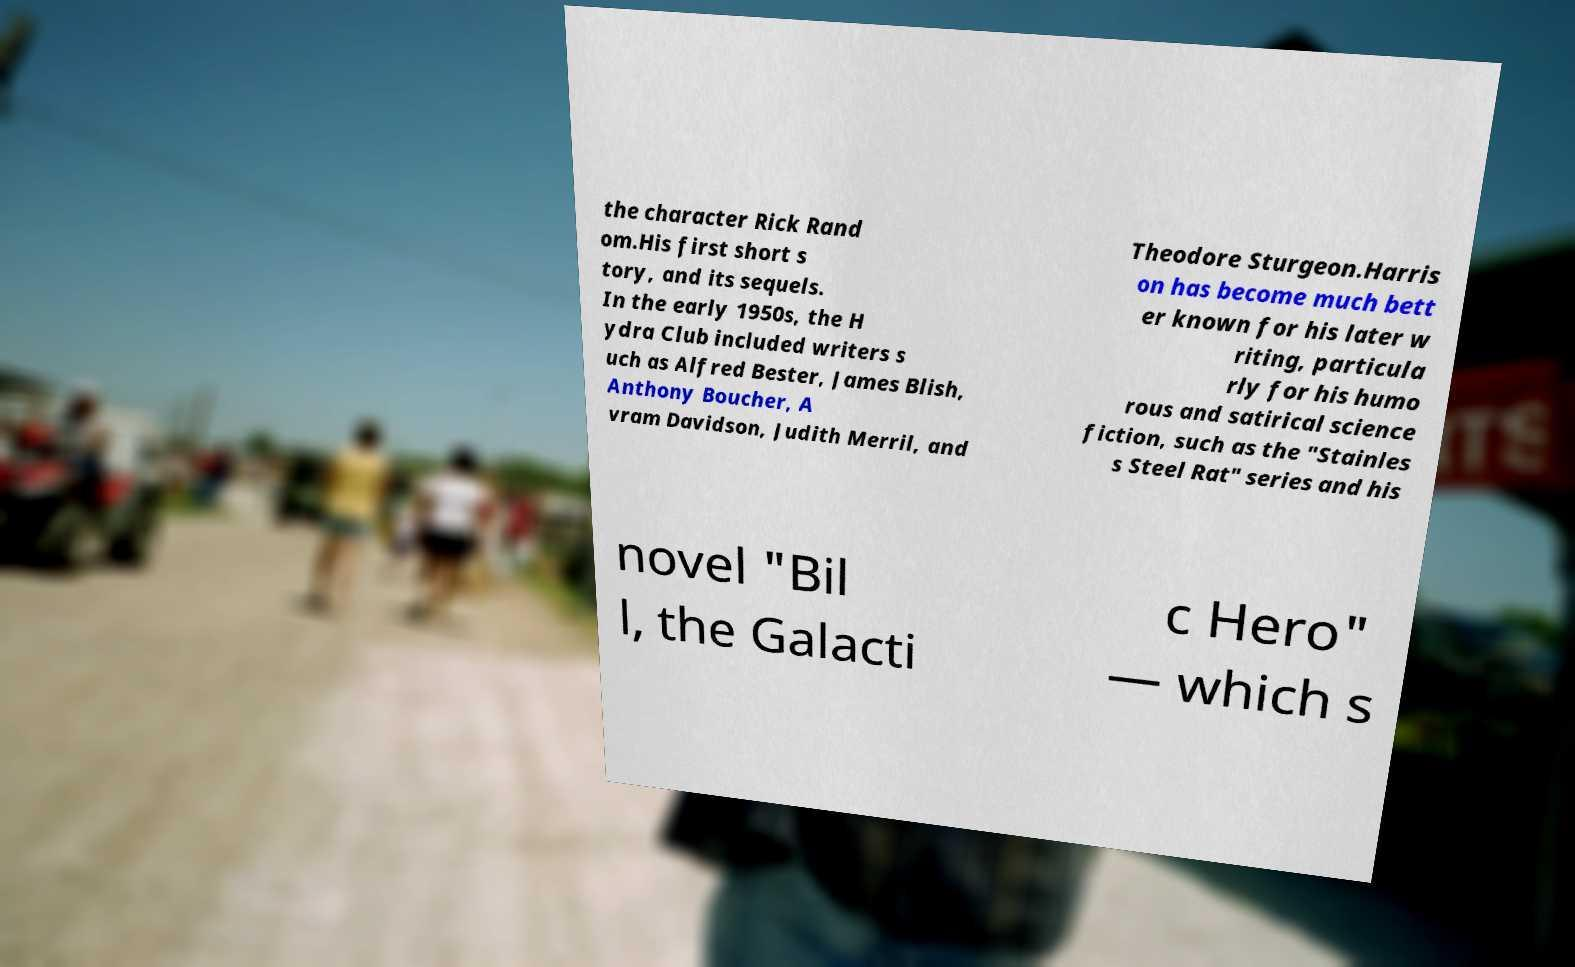Can you accurately transcribe the text from the provided image for me? the character Rick Rand om.His first short s tory, and its sequels. In the early 1950s, the H ydra Club included writers s uch as Alfred Bester, James Blish, Anthony Boucher, A vram Davidson, Judith Merril, and Theodore Sturgeon.Harris on has become much bett er known for his later w riting, particula rly for his humo rous and satirical science fiction, such as the "Stainles s Steel Rat" series and his novel "Bil l, the Galacti c Hero" — which s 